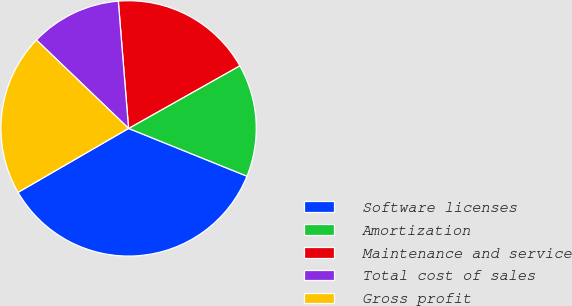Convert chart. <chart><loc_0><loc_0><loc_500><loc_500><pie_chart><fcel>Software licenses<fcel>Amortization<fcel>Maintenance and service<fcel>Total cost of sales<fcel>Gross profit<nl><fcel>35.55%<fcel>14.27%<fcel>18.12%<fcel>11.55%<fcel>20.52%<nl></chart> 